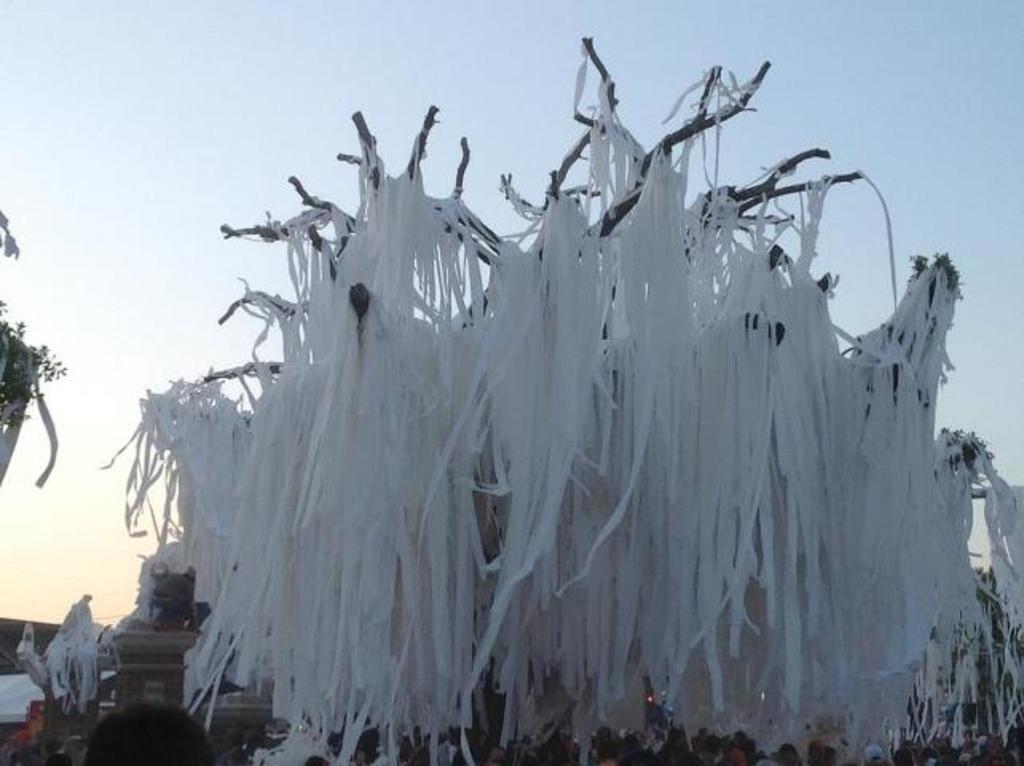Describe this image in one or two sentences. This is an outside view. Here I can see many white color ribbons are attached to a tree. At the bottom, I can see a crowd of people. At the top, I can see the sky. 